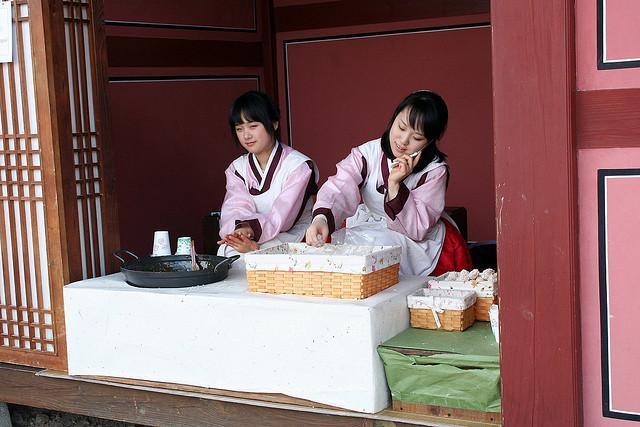How many people can you see?
Give a very brief answer. 2. How many bicycles are on the other side of the street?
Give a very brief answer. 0. 